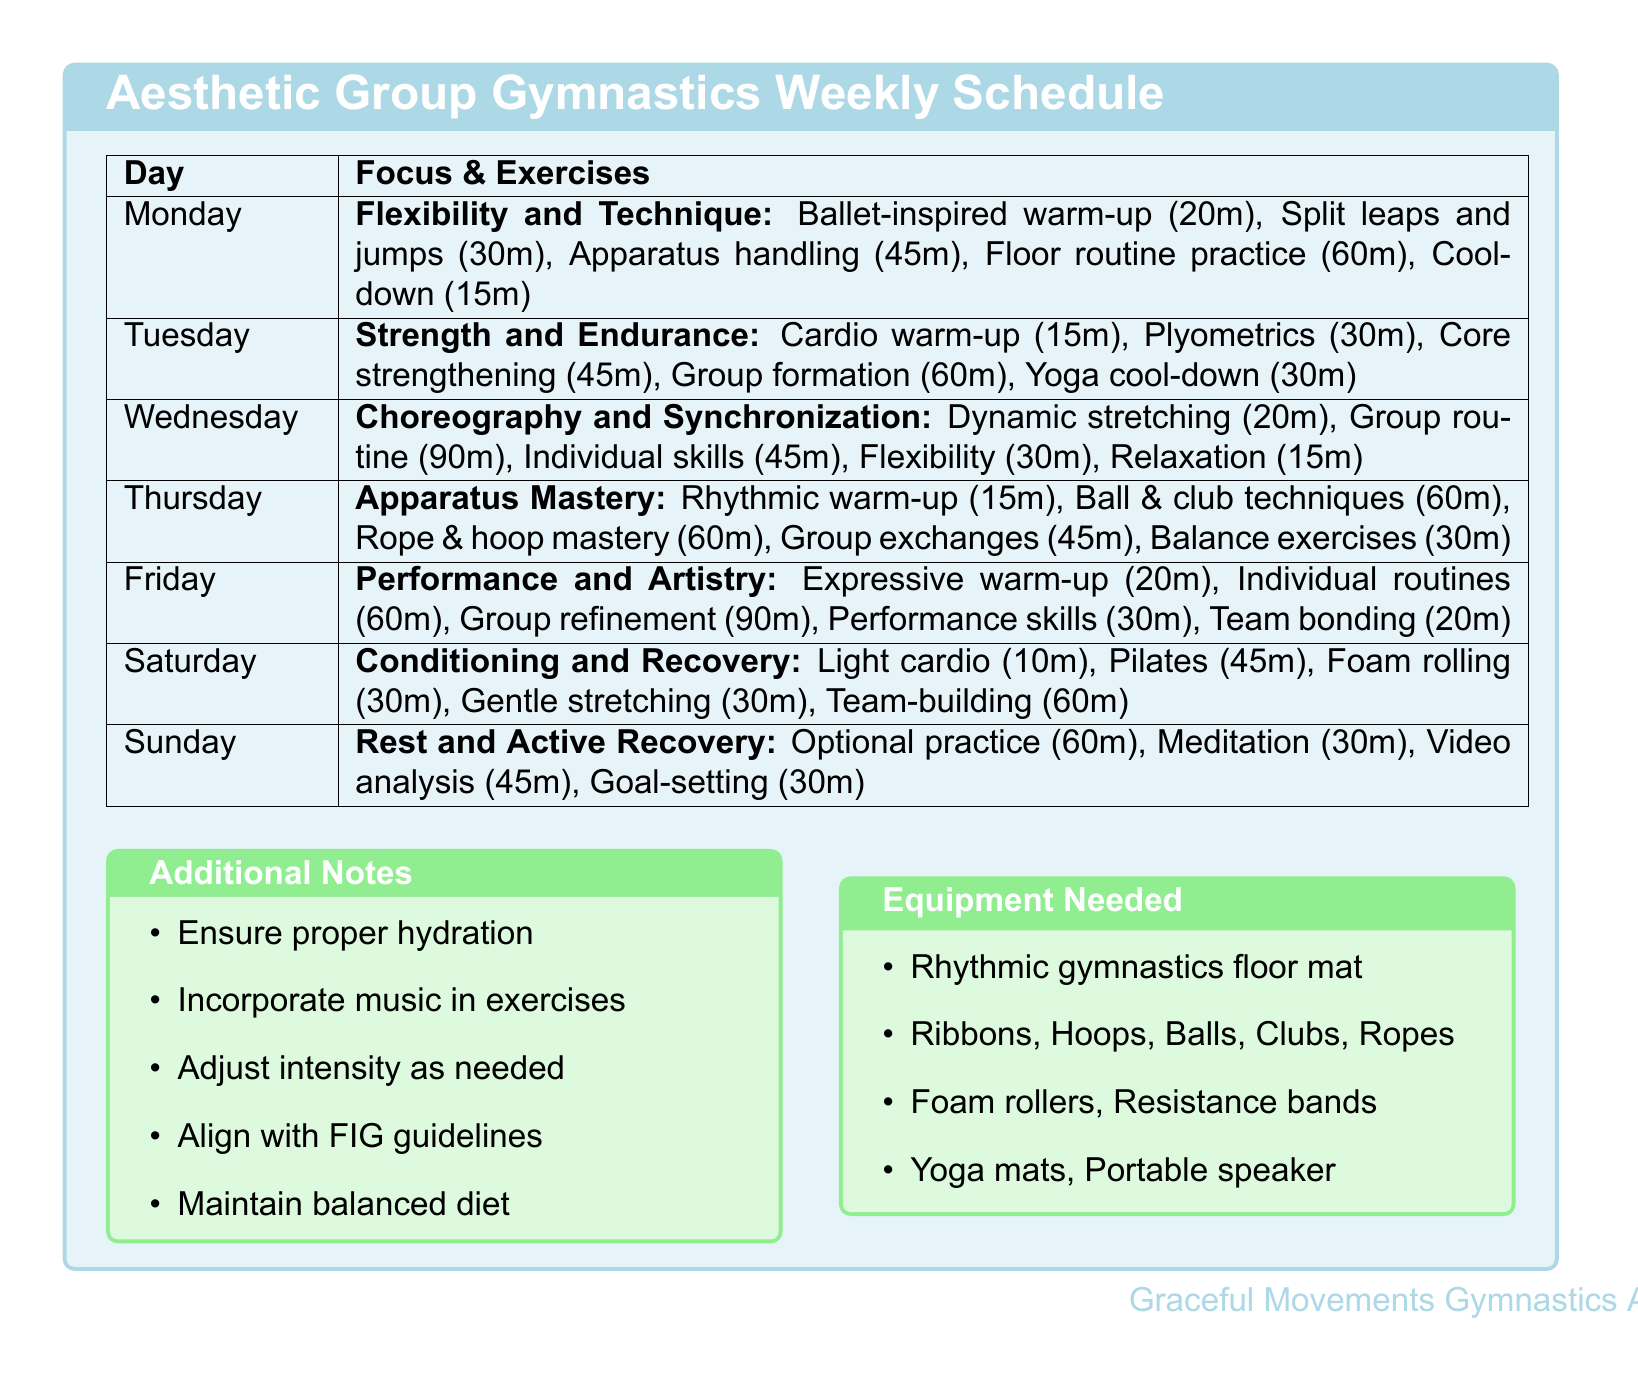What is the focus of Monday's training? The focus of Monday's training is stated in the document as "Flexibility and Technique."
Answer: Flexibility and Technique How long is the group routine practice on Wednesday? The duration of the group routine practice is specified in the document as 90 minutes.
Answer: 90 minutes What type of warm-up is included on Tuesday? The document mentions "Cardiovascular warm-up" for Tuesday, indicating the specific type of warm-up.
Answer: Cardiovascular warm-up What is the duration of the core strengthening exercise on Tuesday? The document states that core strengthening lasts for 45 minutes on Tuesday, which is the required information.
Answer: 45 minutes Which exercise focuses on relaxation and visualization? The exercise focusing on relaxation and visualization is listed in the document for Wednesday's training as "Relaxation and visualization."
Answer: Relaxation and visualization What is one piece of equipment needed for the training? The document lists multiple items, and "Ribbons" is one of the mentioned pieces of equipment.
Answer: Ribbons What does the Friday focus on? The Friday training focus is identified in the document as "Performance and Artistry."
Answer: Performance and Artistry How long is the individual routine polishing on Friday? The duration of individual routine polishing on Friday is indicated as 60 minutes in the document.
Answer: 60 minutes What type of session is included on Sunday for mind wellness? The document specifically indicates a "Meditation and mindfulness session" for Sunday, reflecting the content of the document.
Answer: Meditation and mindfulness session 